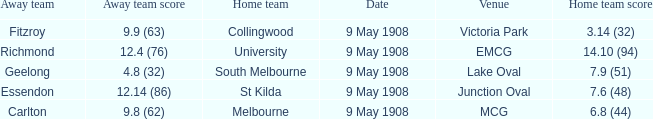Name the home team score for south melbourne home team 7.9 (51). 